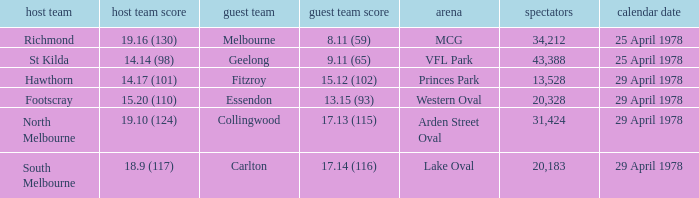Would you mind parsing the complete table? {'header': ['host team', 'host team score', 'guest team', 'guest team score', 'arena', 'spectators', 'calendar date'], 'rows': [['Richmond', '19.16 (130)', 'Melbourne', '8.11 (59)', 'MCG', '34,212', '25 April 1978'], ['St Kilda', '14.14 (98)', 'Geelong', '9.11 (65)', 'VFL Park', '43,388', '25 April 1978'], ['Hawthorn', '14.17 (101)', 'Fitzroy', '15.12 (102)', 'Princes Park', '13,528', '29 April 1978'], ['Footscray', '15.20 (110)', 'Essendon', '13.15 (93)', 'Western Oval', '20,328', '29 April 1978'], ['North Melbourne', '19.10 (124)', 'Collingwood', '17.13 (115)', 'Arden Street Oval', '31,424', '29 April 1978'], ['South Melbourne', '18.9 (117)', 'Carlton', '17.14 (116)', 'Lake Oval', '20,183', '29 April 1978']]} What was the away team that played at Princes Park? Fitzroy. 